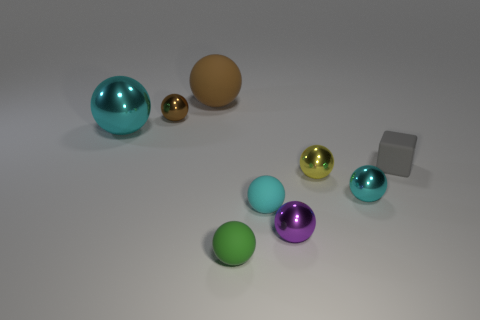Subtract all cyan cylinders. How many cyan spheres are left? 3 Subtract 2 spheres. How many spheres are left? 6 Subtract all green balls. How many balls are left? 7 Subtract all cyan metallic spheres. How many spheres are left? 6 Add 1 purple metallic objects. How many objects exist? 10 Subtract all gray balls. Subtract all brown blocks. How many balls are left? 8 Subtract all blocks. How many objects are left? 8 Subtract all cubes. Subtract all tiny brown metal cylinders. How many objects are left? 8 Add 5 tiny gray matte objects. How many tiny gray matte objects are left? 6 Add 7 large brown things. How many large brown things exist? 8 